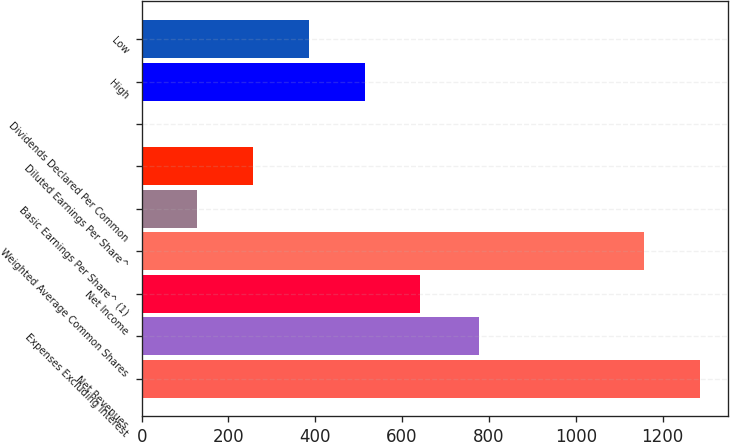<chart> <loc_0><loc_0><loc_500><loc_500><bar_chart><fcel>Net Revenues<fcel>Expenses Excluding Interest<fcel>Net Income<fcel>Weighted Average Common Shares<fcel>Basic Earnings Per Share^ (1)<fcel>Diluted Earnings Per Share^<fcel>Dividends Declared Per Common<fcel>High<fcel>Low<nl><fcel>1286.39<fcel>777<fcel>642.01<fcel>1158<fcel>128.45<fcel>256.84<fcel>0.06<fcel>513.62<fcel>385.23<nl></chart> 